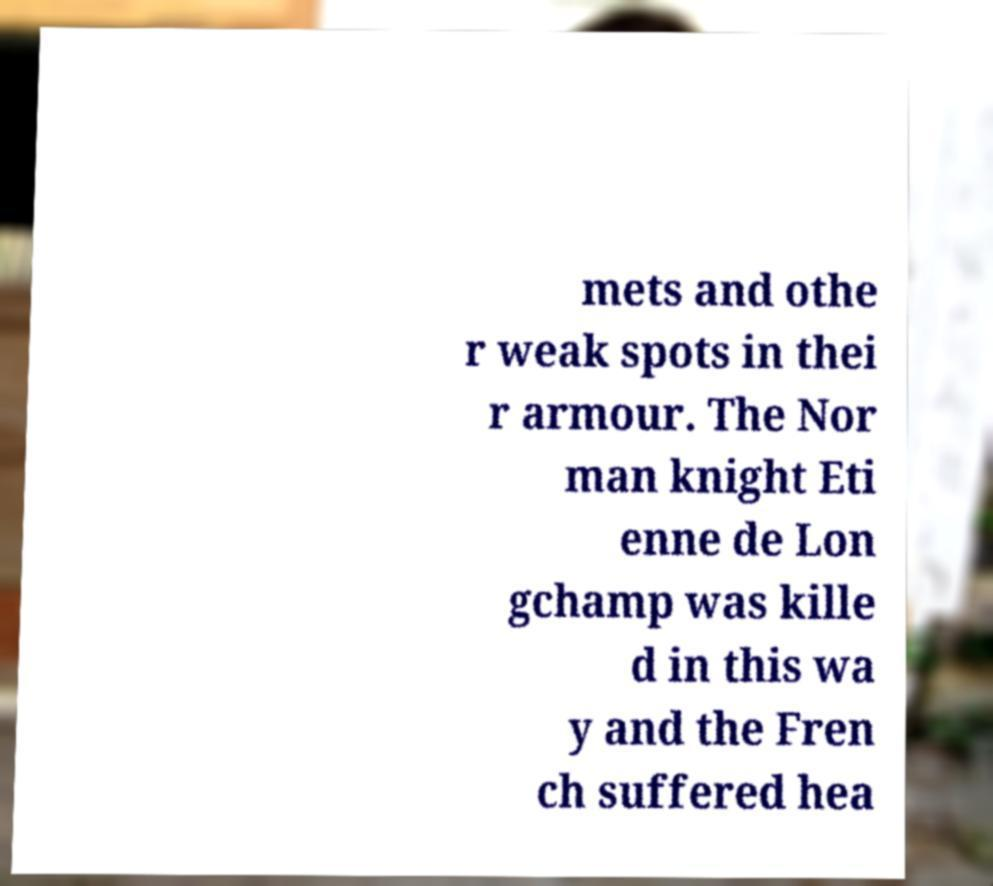I need the written content from this picture converted into text. Can you do that? mets and othe r weak spots in thei r armour. The Nor man knight Eti enne de Lon gchamp was kille d in this wa y and the Fren ch suffered hea 